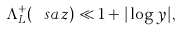<formula> <loc_0><loc_0><loc_500><loc_500>\Lambda _ { L } ^ { + } ( \ s a z ) \ll 1 + | \log y | ,</formula> 